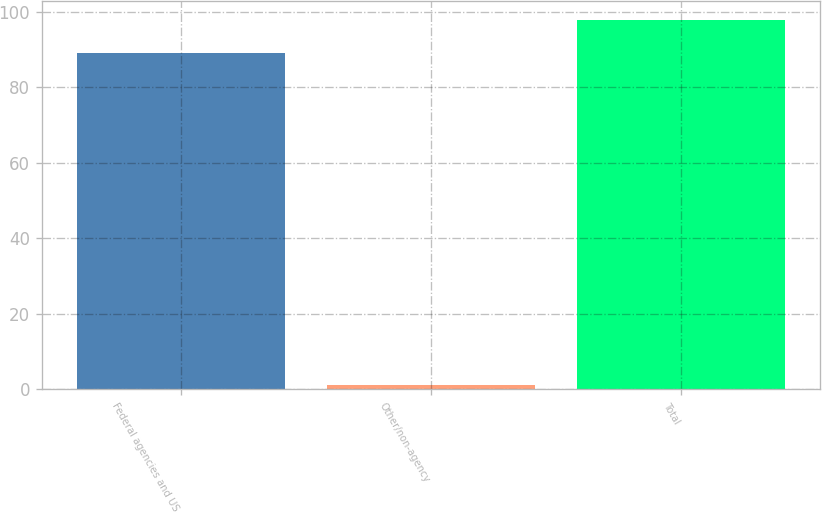Convert chart. <chart><loc_0><loc_0><loc_500><loc_500><bar_chart><fcel>Federal agencies and US<fcel>Other/non-agency<fcel>Total<nl><fcel>89<fcel>1<fcel>97.9<nl></chart> 